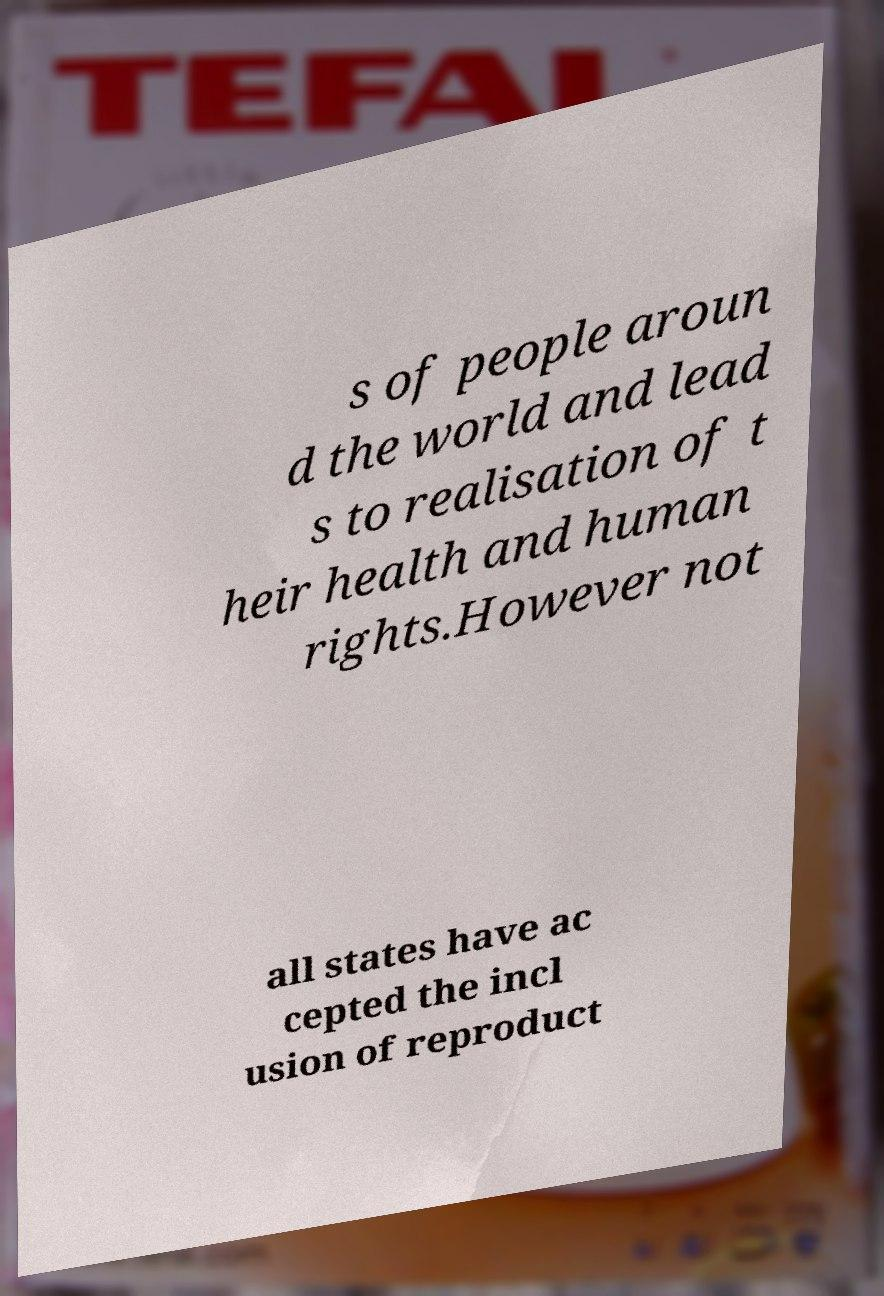Can you read and provide the text displayed in the image?This photo seems to have some interesting text. Can you extract and type it out for me? s of people aroun d the world and lead s to realisation of t heir health and human rights.However not all states have ac cepted the incl usion of reproduct 